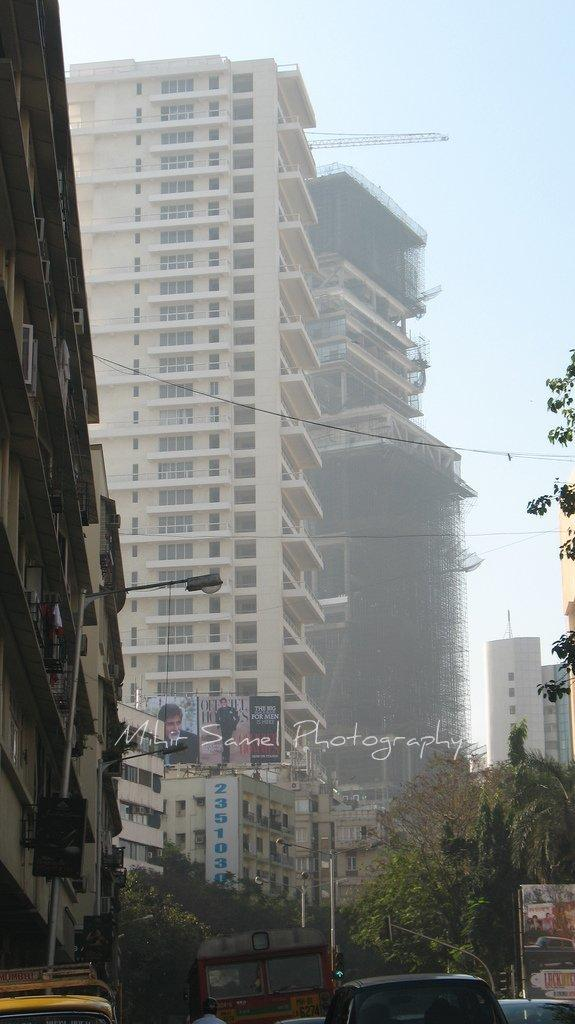What can be seen beside the road in the image? There are buildings beside the road in the image. What is happening on the road in the image? There are vehicles moving on the road in the image. What type of ground can be seen in the image? There is no specific mention of the ground in the provided facts, so it cannot be determined from the image. Is there a truck smashing into the buildings in the image? There is no indication of a truck or any collision in the image; it only shows buildings beside the road and vehicles moving on the road. 